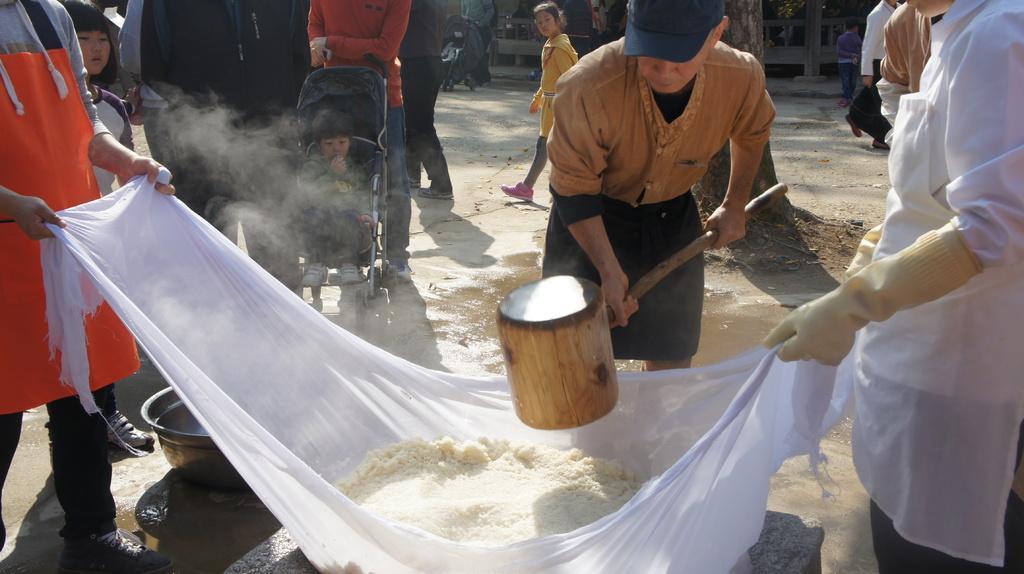How would you summarize this image in a sentence or two? In the image in the center, we can see three persons are standing. Two persons are holding cloth and one person holding some object. In the cloth, we can see some food item. In the background, we can see a few people are walking and they are holding some objects and a few other objects. 